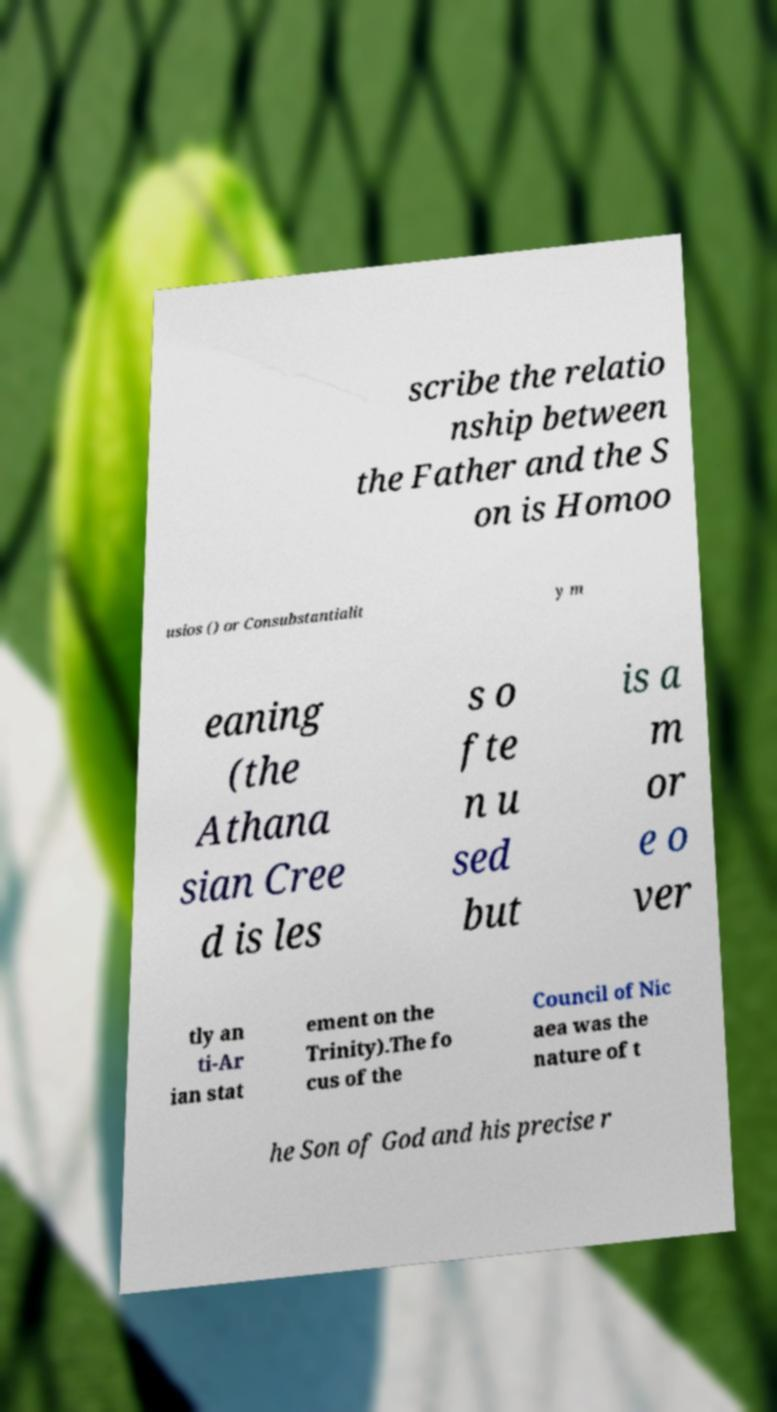Please read and relay the text visible in this image. What does it say? scribe the relatio nship between the Father and the S on is Homoo usios () or Consubstantialit y m eaning (the Athana sian Cree d is les s o fte n u sed but is a m or e o ver tly an ti-Ar ian stat ement on the Trinity).The fo cus of the Council of Nic aea was the nature of t he Son of God and his precise r 